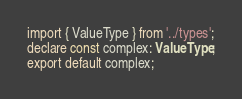<code> <loc_0><loc_0><loc_500><loc_500><_TypeScript_>import { ValueType } from '../types';
declare const complex: ValueType;
export default complex;
</code> 